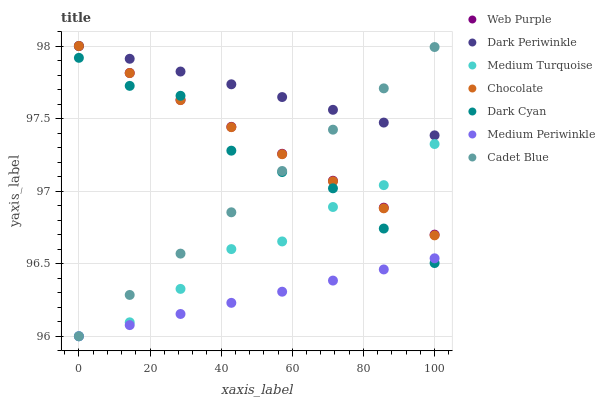Does Medium Periwinkle have the minimum area under the curve?
Answer yes or no. Yes. Does Dark Periwinkle have the maximum area under the curve?
Answer yes or no. Yes. Does Chocolate have the minimum area under the curve?
Answer yes or no. No. Does Chocolate have the maximum area under the curve?
Answer yes or no. No. Is Dark Periwinkle the smoothest?
Answer yes or no. Yes. Is Dark Cyan the roughest?
Answer yes or no. Yes. Is Medium Periwinkle the smoothest?
Answer yes or no. No. Is Medium Periwinkle the roughest?
Answer yes or no. No. Does Cadet Blue have the lowest value?
Answer yes or no. Yes. Does Chocolate have the lowest value?
Answer yes or no. No. Does Dark Periwinkle have the highest value?
Answer yes or no. Yes. Does Medium Periwinkle have the highest value?
Answer yes or no. No. Is Medium Turquoise less than Dark Periwinkle?
Answer yes or no. Yes. Is Web Purple greater than Medium Periwinkle?
Answer yes or no. Yes. Does Medium Turquoise intersect Dark Cyan?
Answer yes or no. Yes. Is Medium Turquoise less than Dark Cyan?
Answer yes or no. No. Is Medium Turquoise greater than Dark Cyan?
Answer yes or no. No. Does Medium Turquoise intersect Dark Periwinkle?
Answer yes or no. No. 